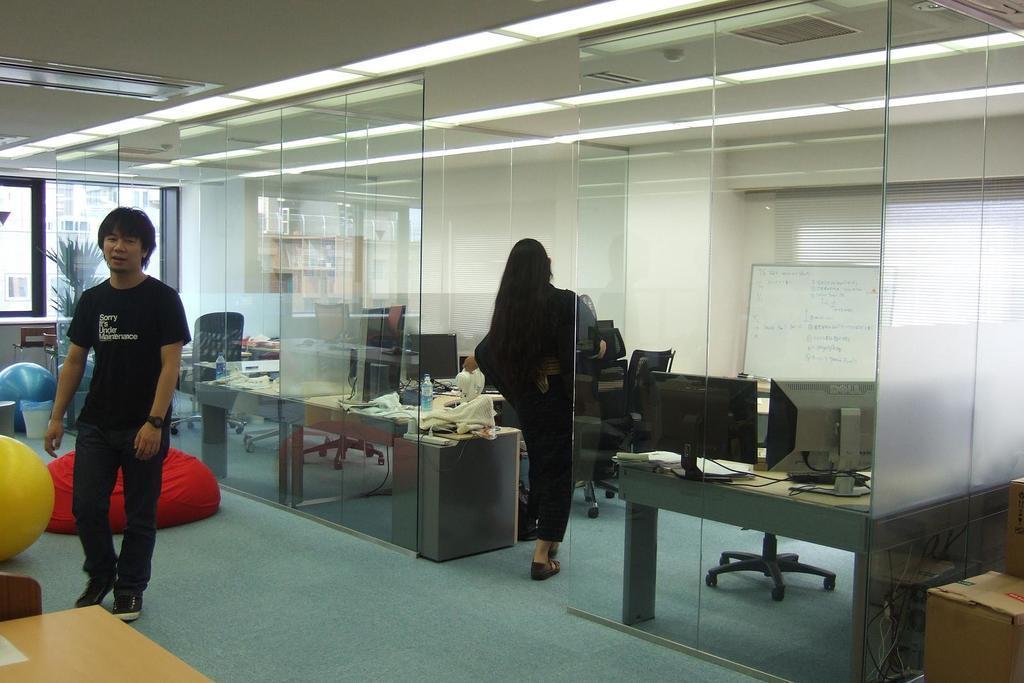Could you give a brief overview of what you see in this image? In this image we can see two persons standing on the floor. To the left side we can see two balls placed on the ground. To the right side of the image we can see a board and two monitors placed on a table. In the background we can see a plant and a window. 